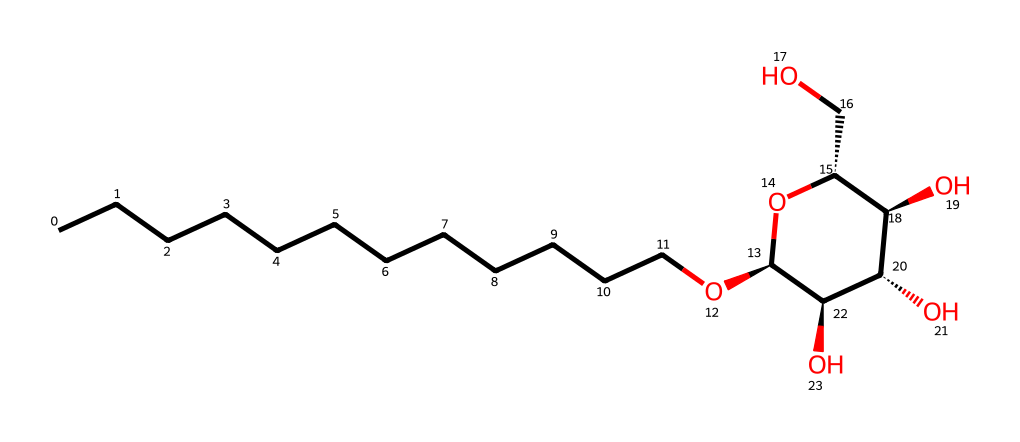What is the main functional group present in alkyl polyglucoside? The chemical contains ether (O) and hydroxy (OH) groups, which are typical functional groups in surfactants.
Answer: ether and hydroxy How many carbon atoms are present in this molecule? By counting the number of carbon atoms represented in the SMILES structure, there are 12 carbon atoms in the straight alkyl chain.
Answer: 12 What type of surfactant is alkyl polyglucoside classified as? Alkyl polyglucoside is classified as a nonionic surfactant due to the lack of charged groups in its structure.
Answer: nonionic How many hydroxyl groups are in the structure? By analyzing the parent sugar part of the chemical, there are 4 hydroxyl (-OH) groups attached to the sugar ring.
Answer: 4 How does the length of the alkyl chain affect the surfactant's properties? The longer the alkyl chain, the more lipophilic (oil-attracting) the surfactant becomes, which enhances emulsification and surfactant properties in cleaners.
Answer: enhances emulsification What does the presence of a sugar moiety suggest about the surfactant's environmental impact? The sugar moiety indicates that alkyl polyglucoside is biodegradable and considered eco-friendly, thus having a lower environmental impact.
Answer: biodegradable 